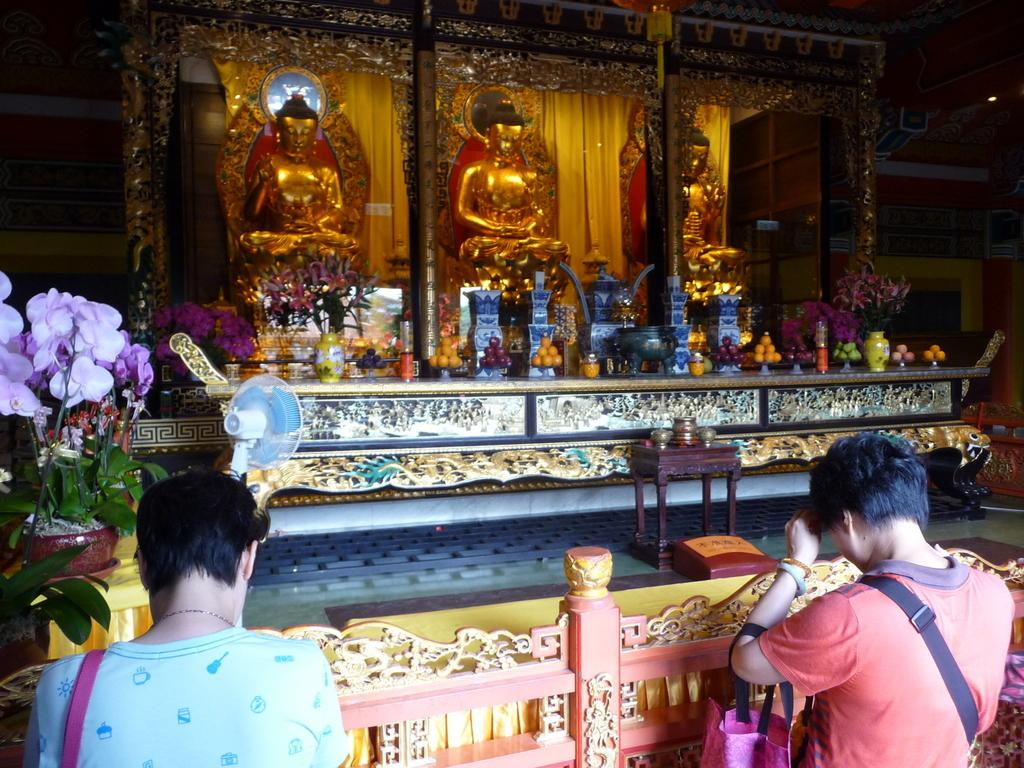What activity are the persons at the bottom of the image engaged in? The persons at the bottom of the image are fencing. What can be seen in the background of the image? In the background of the image, there are statues, pillars, a flower vase, fruits, and jars. Can you describe the statues in the background? Unfortunately, the facts provided do not give any details about the statues, so we cannot describe them. What type of ant can be seen crawling on the jars in the background? There are no ants present in the image, so we cannot answer this question. What kind of bomb is depicted in the image? There is no bomb present in the image. 